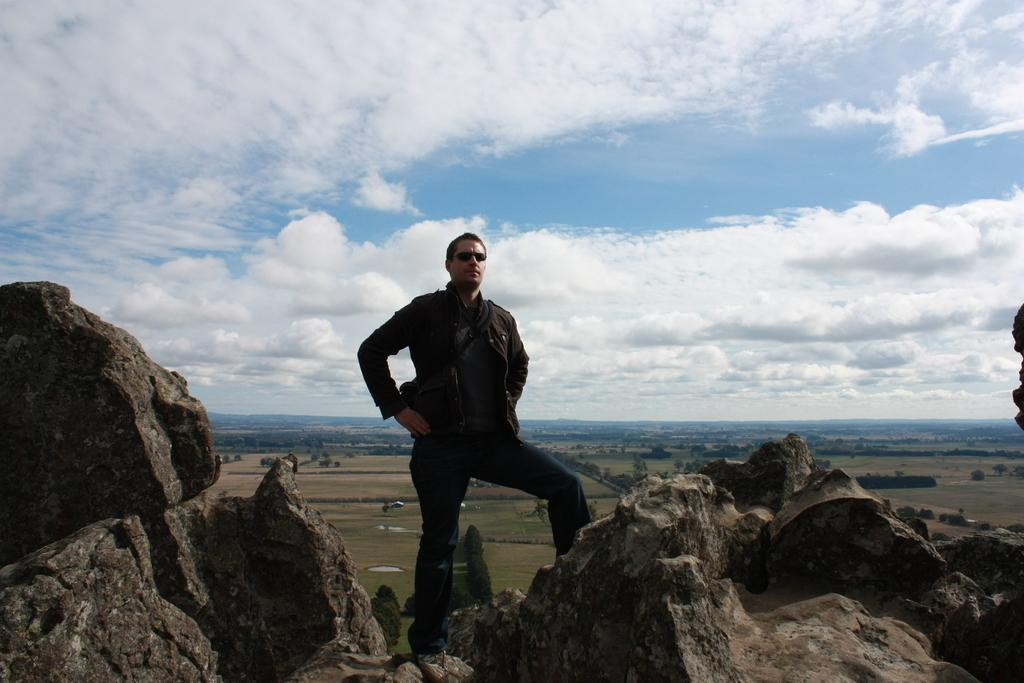What type of natural elements can be seen in the image? There are rocks in the image. Can you describe the person in the image? There is a person standing in the front of the image. What can be seen in the background of the image? There are trees in the background of the image. What is visible at the top of the image? The sky is visible in the image, and clouds are present in the sky. What type of pipe can be seen in the image? There is no pipe present in the image. What is the person in the image regretting? There is no indication of regret in the image, as it only shows a person standing in front of rocks with trees and clouds in the background. 